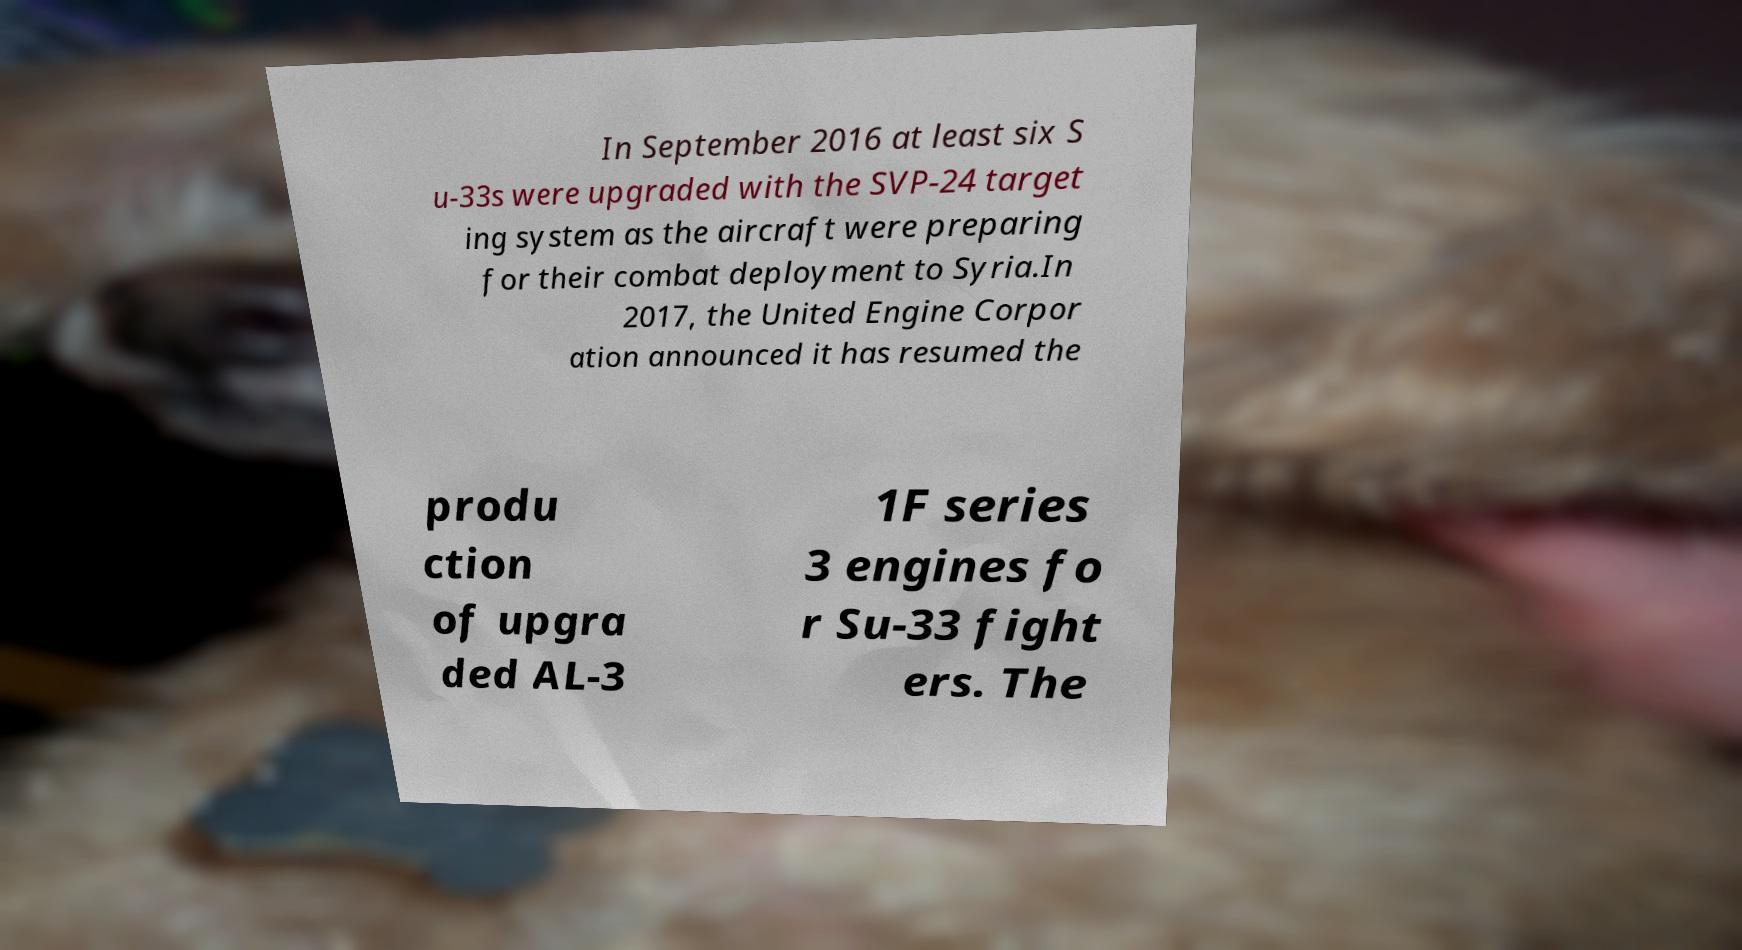Please identify and transcribe the text found in this image. In September 2016 at least six S u-33s were upgraded with the SVP-24 target ing system as the aircraft were preparing for their combat deployment to Syria.In 2017, the United Engine Corpor ation announced it has resumed the produ ction of upgra ded AL-3 1F series 3 engines fo r Su-33 fight ers. The 